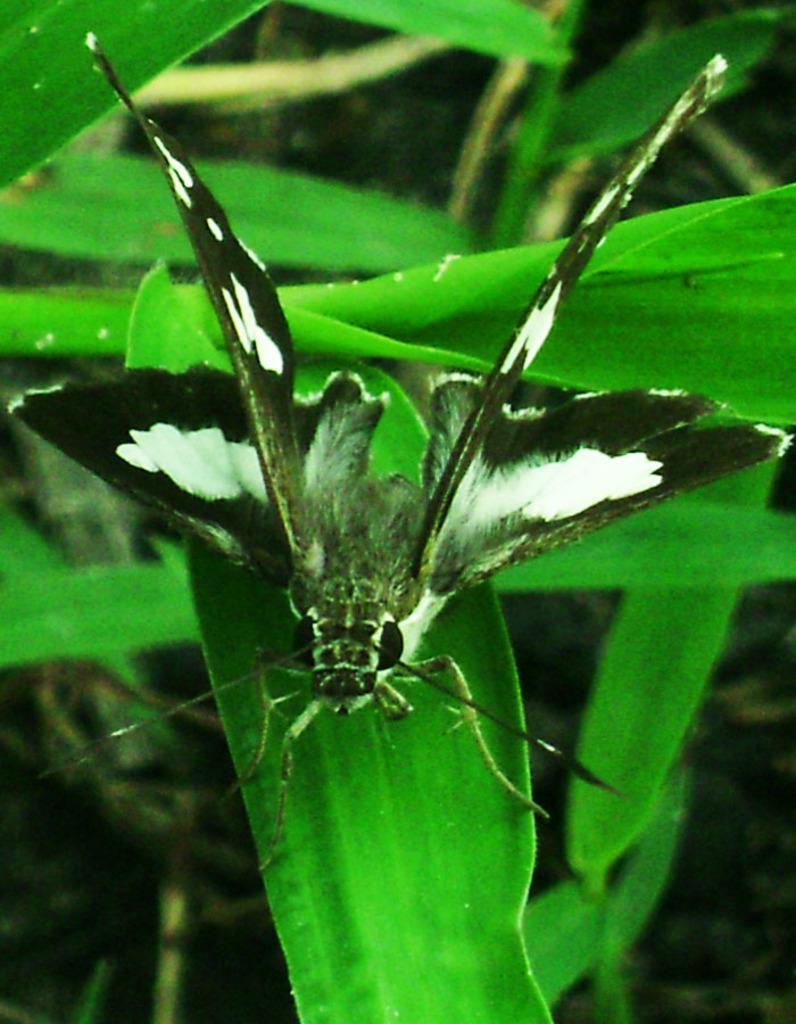What is on the leaf in the image? There is an insect on a leaf in the image. What can be seen in the background of the image? There are leaves visible in the background of the image. What type of pipe is being smoked by the insect in the image? There is no pipe present in the image; it features an insect on a leaf and leaves in the background. 